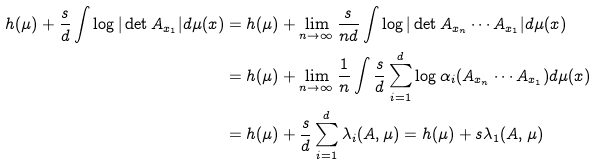Convert formula to latex. <formula><loc_0><loc_0><loc_500><loc_500>h ( \mu ) + \frac { s } { d } \int \log | \det A _ { x _ { 1 } } | d \mu ( x ) & = h ( \mu ) + \lim _ { n \to \infty } \frac { s } { n d } \int \log | \det A _ { x _ { n } } \cdots A _ { x _ { 1 } } | d \mu ( x ) \\ & = h ( \mu ) + \lim _ { n \to \infty } \frac { 1 } { n } \int \frac { s } { d } \sum _ { i = 1 } ^ { d } \log \alpha _ { i } ( A _ { x _ { n } } \cdots A _ { x _ { 1 } } ) d \mu ( x ) \\ & = h ( \mu ) + \frac { s } { d } \sum _ { i = 1 } ^ { d } \lambda _ { i } ( A , \mu ) = h ( \mu ) + s \lambda _ { 1 } ( A , \mu )</formula> 